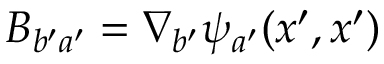Convert formula to latex. <formula><loc_0><loc_0><loc_500><loc_500>B _ { b ^ { \prime } a ^ { \prime } } = \nabla _ { b ^ { \prime } } \psi _ { a ^ { \prime } } ( x ^ { \prime } , x ^ { \prime } )</formula> 